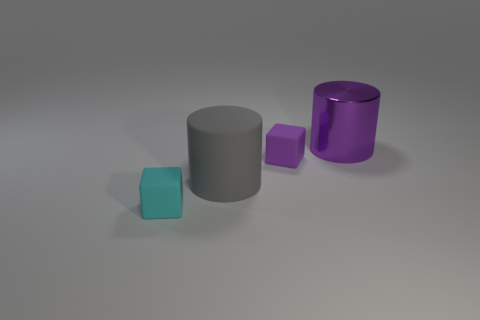Is there any other thing that has the same material as the large purple object?
Offer a very short reply. No. Do the big purple cylinder and the object that is in front of the gray rubber object have the same material?
Offer a very short reply. No. Are there any other things that have the same shape as the large gray matte thing?
Provide a short and direct response. Yes. What color is the object that is right of the cyan matte cube and in front of the small purple rubber block?
Provide a short and direct response. Gray. What is the shape of the large object on the left side of the purple cylinder?
Offer a very short reply. Cylinder. There is a purple thing to the right of the tiny rubber block that is behind the big cylinder left of the metallic cylinder; what is its size?
Provide a short and direct response. Large. What number of cyan cubes are in front of the purple object in front of the large metallic cylinder?
Offer a terse response. 1. There is a object that is both behind the gray matte object and on the left side of the large purple metallic object; what size is it?
Keep it short and to the point. Small. What number of shiny things are tiny cylinders or purple things?
Your answer should be very brief. 1. What is the cyan cube made of?
Offer a terse response. Rubber. 